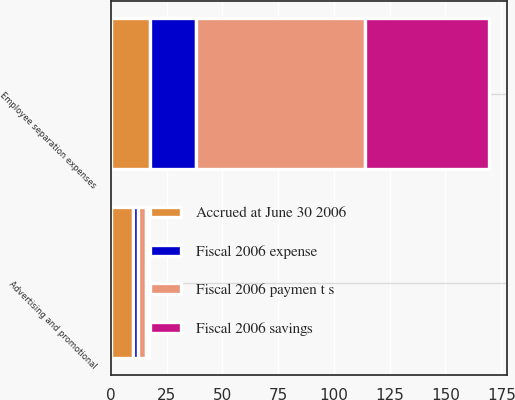Convert chart to OTSL. <chart><loc_0><loc_0><loc_500><loc_500><stacked_bar_chart><ecel><fcel>Employee separation expenses<fcel>Advertising and promotional<nl><fcel>Fiscal 2006 paymen t s<fcel>75.9<fcel>3.7<nl><fcel>Fiscal 2006 expense<fcel>20.7<fcel>2.5<nl><fcel>Fiscal 2006 savings<fcel>55.2<fcel>1.2<nl><fcel>Accrued at June 30 2006<fcel>17.5<fcel>9.8<nl></chart> 